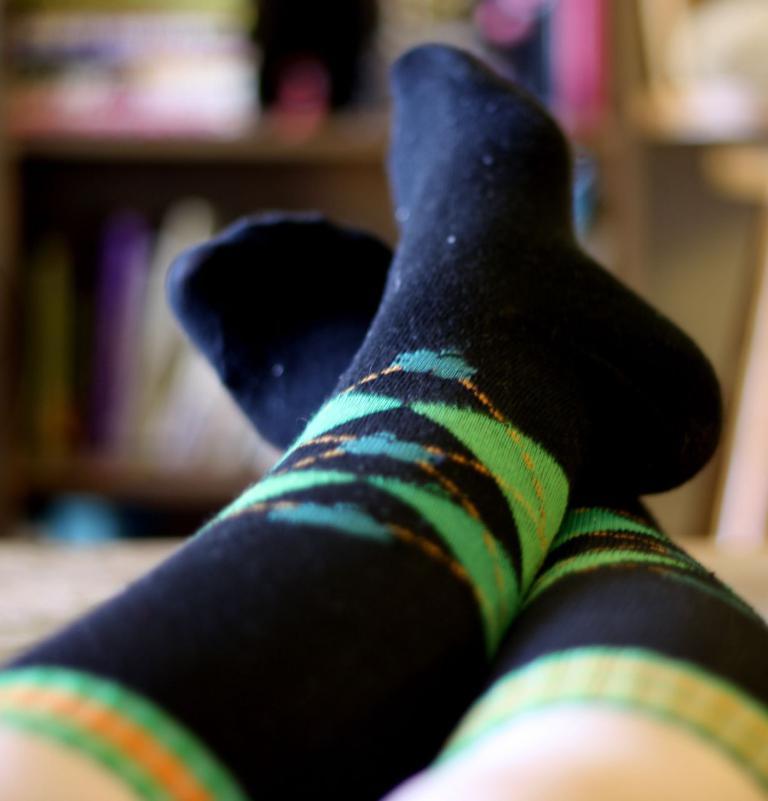Can you describe this image briefly? In this image I can see legs of a person wearing black colour socks. I can also see this image is little bit blurry from background. 